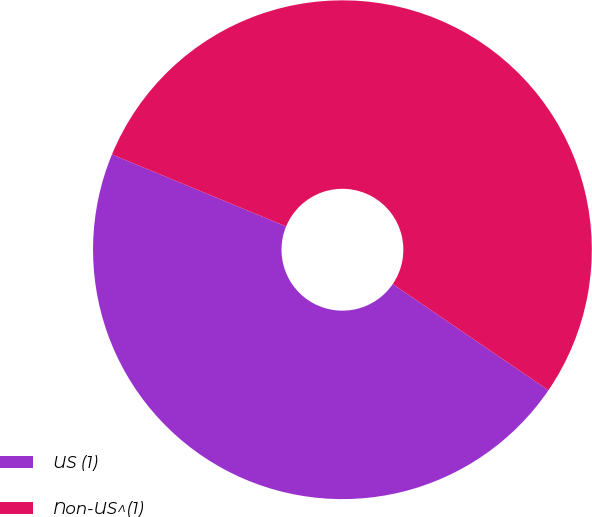Convert chart to OTSL. <chart><loc_0><loc_0><loc_500><loc_500><pie_chart><fcel>US (1)<fcel>Non-US^(1)<nl><fcel>46.71%<fcel>53.29%<nl></chart> 